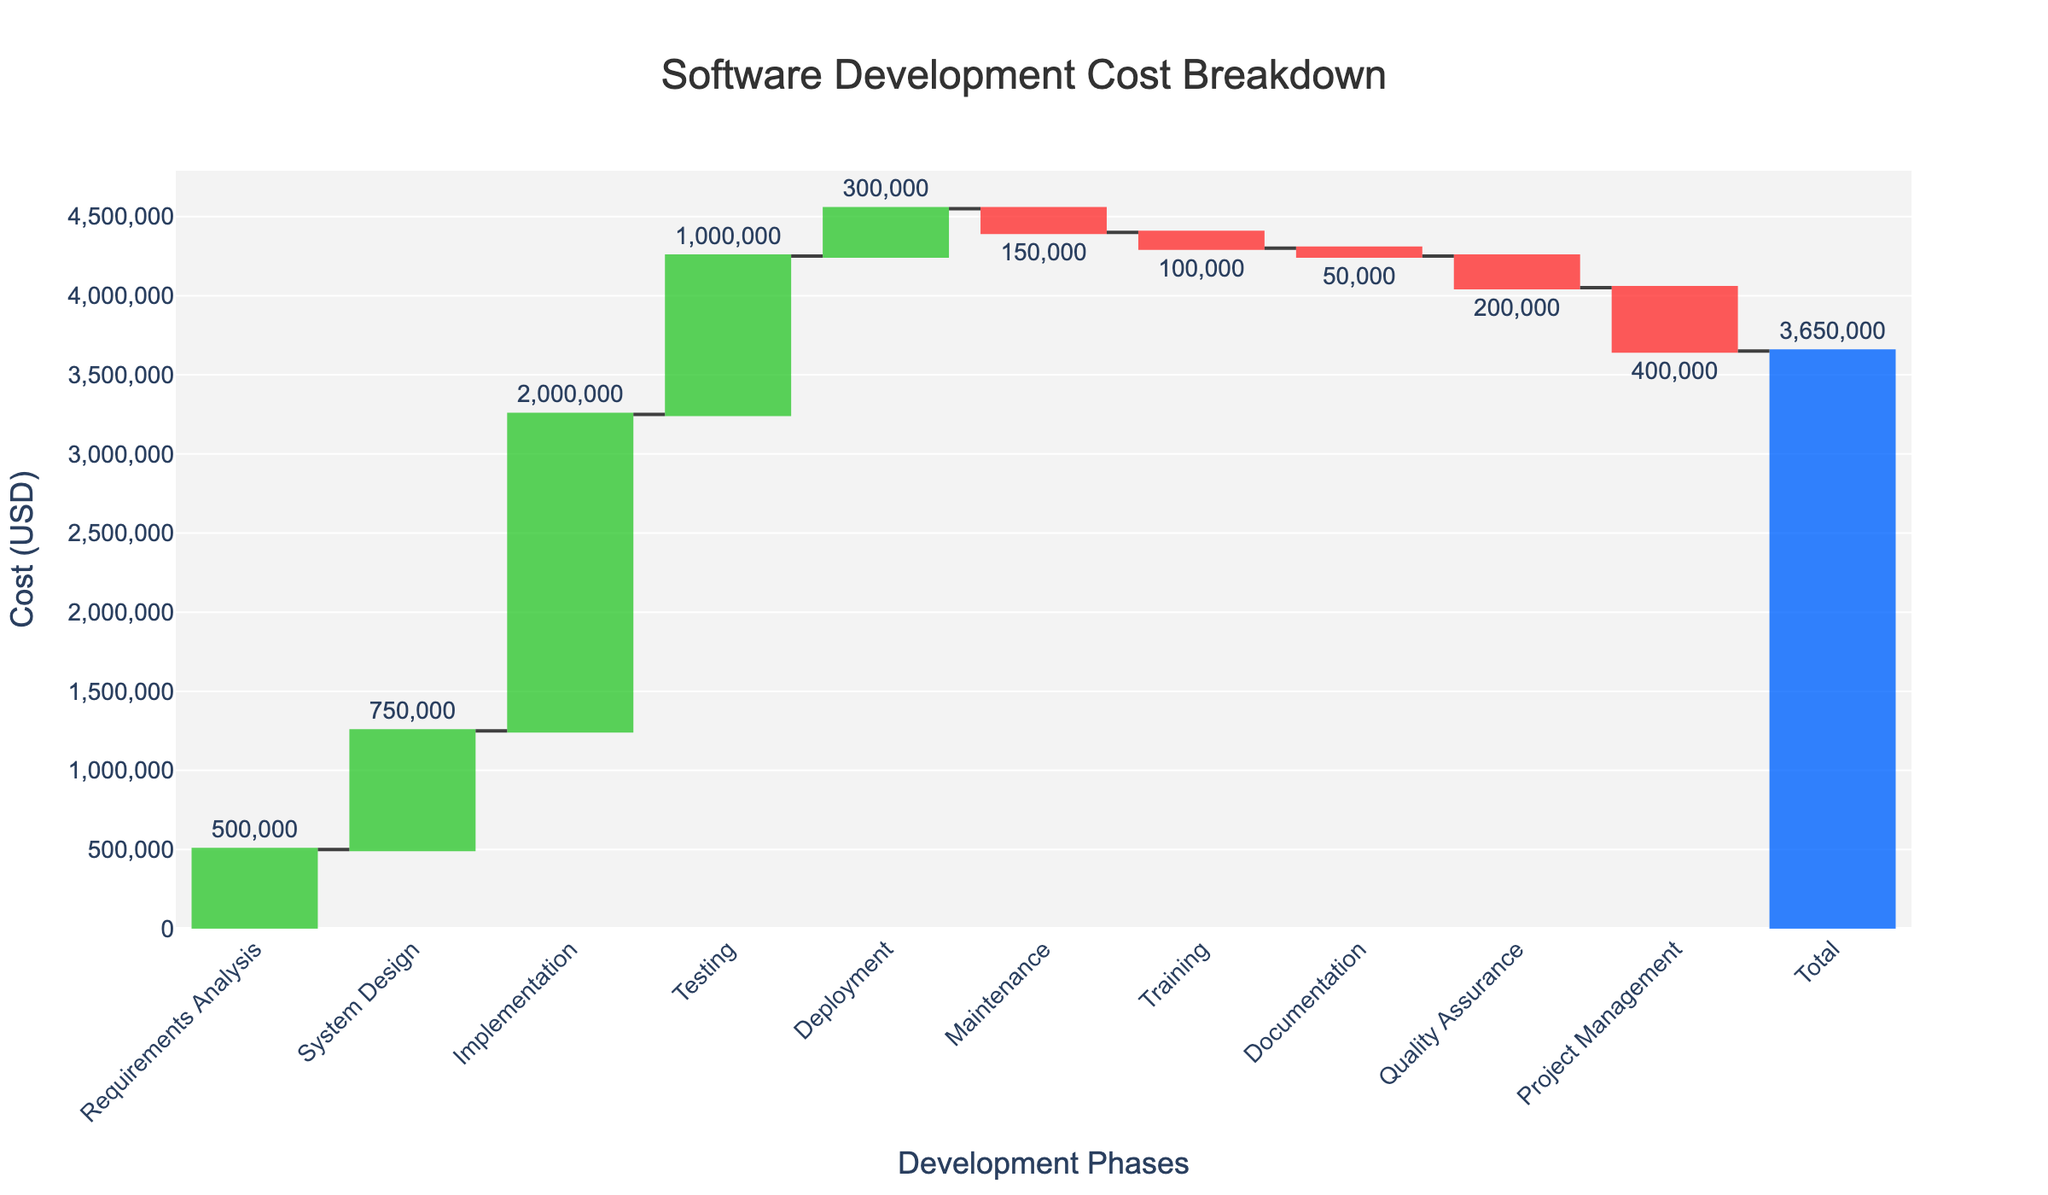What is the title of the waterfall chart? The title of the waterfall chart is usually placed at the top of the figure. It is clearly labeled to give an overview of what the chart represents.
Answer: Software Development Cost Breakdown What is the cost associated with the Implementation phase? To find the cost of the Implementation phase, locate the bar labeled "Implementation" and read the value associated with it.
Answer: 2,000,000 What is the total cost of the software development project? The total cost is usually represented by the last bar in the waterfall chart. It is often colored differently to distinguish it as the cumulative total.
Answer: 3,650,000 How much was spent in the Deployment phase? Locate the bar labeled "Deployment" and observe the value noted. This value represents the cost for the Deployment phase.
Answer: 300,000 Which phase had the highest negative impact on the total cost? Phases with negative impacts are represented by downward bars (often in red). Compare these bars and find the one with the largest absolute value.
Answer: Project Management What is the sum of costs for Requirements Analysis and Testing phases? Add the value for Requirements Analysis and Testing phases by locating their respective bars and summing their values. 500,000 + 1,000,000 = 1,500,000
Answer: 1,500,000 Which phase contributed the most to the overall cost? The phase with the highest bar in the chart indicates the largest contribution to the overall cost.
Answer: Implementation By how much did the Maintenance phase reduce the total cost? Locate the Maintenance phase bar, note its value (which will be negative), and understand that this value is subtracted from the total.
Answer: 150,000 Compare the costs of System Design and Quality Assurance. Which one is higher and by how much? Locate the bars for System Design and Quality Assurance. System Design is at 750,000 and Quality Assurance is -200,000. Calculate the difference. 750,000 - (-200,000) = 950,000
Answer: System Design, by 950,000 What is the combined effect of the negative contributions (Maintenance, Training, Documentation, Quality Assurance, Project Management) on the total cost? Add up all the negative values: -150,000 + -100,000 + -50,000 + -200,000 + -400,000. This sum gives the negative impact. -150,000 - 100,000 - 50,000 - 200,000 - 400,000 = -900,000
Answer: -900,000 